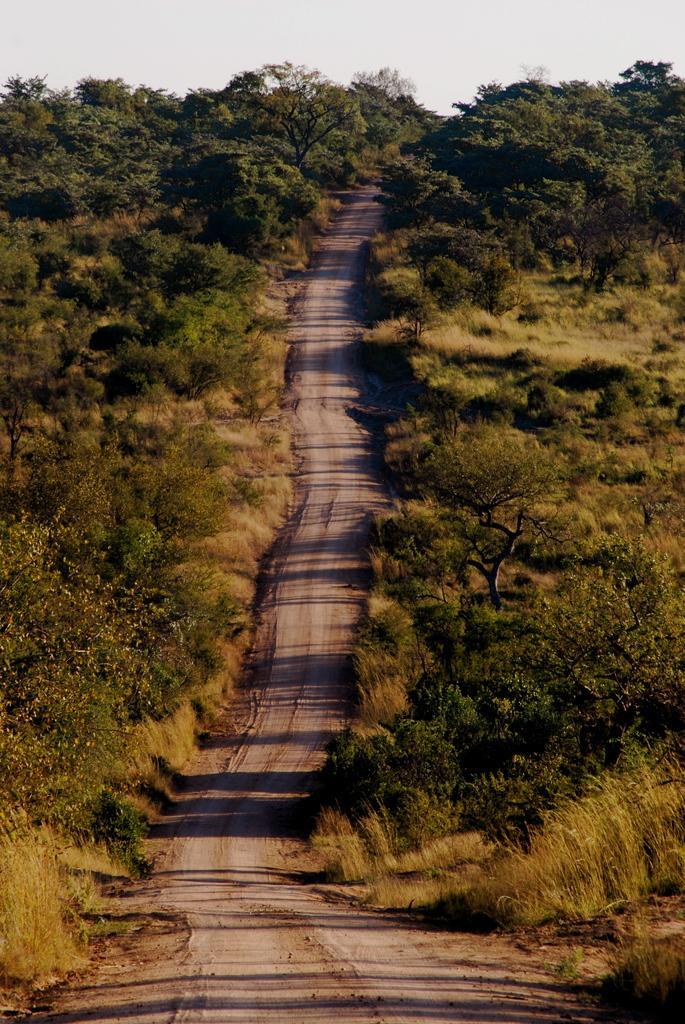Could you give a brief overview of what you see in this image? In this image we can see a road in the middle and there are few trees and plants on both sides of the road and the sky in the background. 